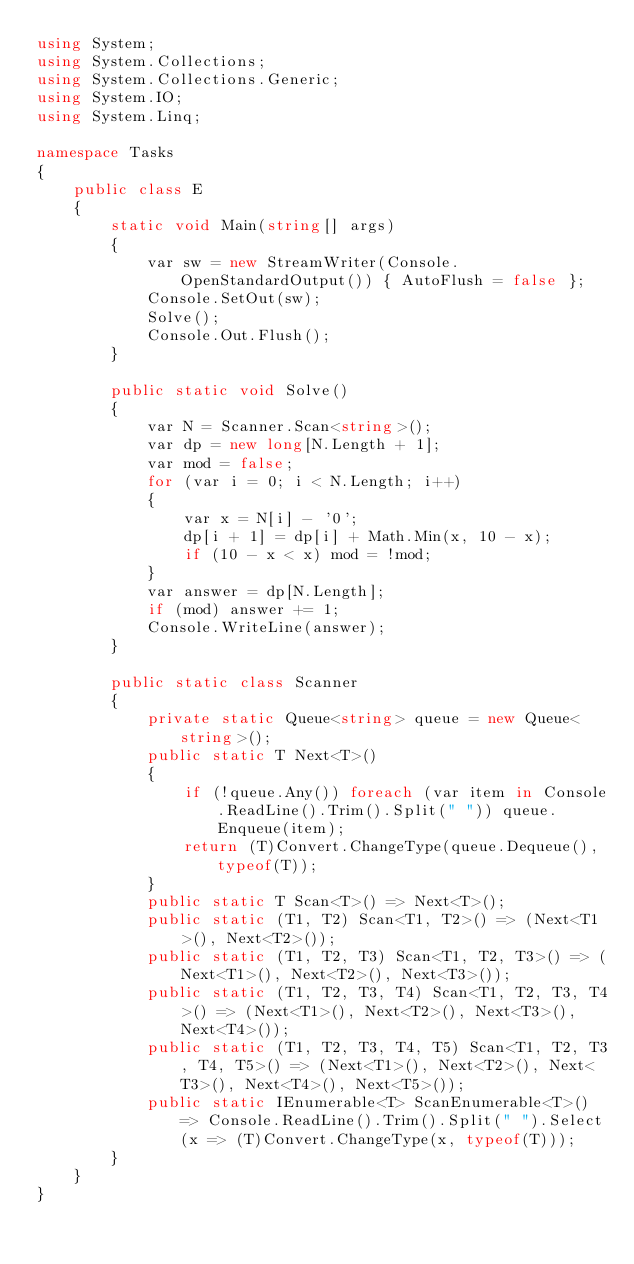<code> <loc_0><loc_0><loc_500><loc_500><_C#_>using System;
using System.Collections;
using System.Collections.Generic;
using System.IO;
using System.Linq;

namespace Tasks
{
    public class E
    {
        static void Main(string[] args)
        {
            var sw = new StreamWriter(Console.OpenStandardOutput()) { AutoFlush = false };
            Console.SetOut(sw);
            Solve();
            Console.Out.Flush();
        }

        public static void Solve()
        {
            var N = Scanner.Scan<string>();
            var dp = new long[N.Length + 1];
            var mod = false;
            for (var i = 0; i < N.Length; i++)
            {
                var x = N[i] - '0';
                dp[i + 1] = dp[i] + Math.Min(x, 10 - x);
                if (10 - x < x) mod = !mod;
            }
            var answer = dp[N.Length];
            if (mod) answer += 1;
            Console.WriteLine(answer);
        }

        public static class Scanner
        {
            private static Queue<string> queue = new Queue<string>();
            public static T Next<T>()
            {
                if (!queue.Any()) foreach (var item in Console.ReadLine().Trim().Split(" ")) queue.Enqueue(item);
                return (T)Convert.ChangeType(queue.Dequeue(), typeof(T));
            }
            public static T Scan<T>() => Next<T>();
            public static (T1, T2) Scan<T1, T2>() => (Next<T1>(), Next<T2>());
            public static (T1, T2, T3) Scan<T1, T2, T3>() => (Next<T1>(), Next<T2>(), Next<T3>());
            public static (T1, T2, T3, T4) Scan<T1, T2, T3, T4>() => (Next<T1>(), Next<T2>(), Next<T3>(), Next<T4>());
            public static (T1, T2, T3, T4, T5) Scan<T1, T2, T3, T4, T5>() => (Next<T1>(), Next<T2>(), Next<T3>(), Next<T4>(), Next<T5>());
            public static IEnumerable<T> ScanEnumerable<T>() => Console.ReadLine().Trim().Split(" ").Select(x => (T)Convert.ChangeType(x, typeof(T)));
        }
    }
}
</code> 